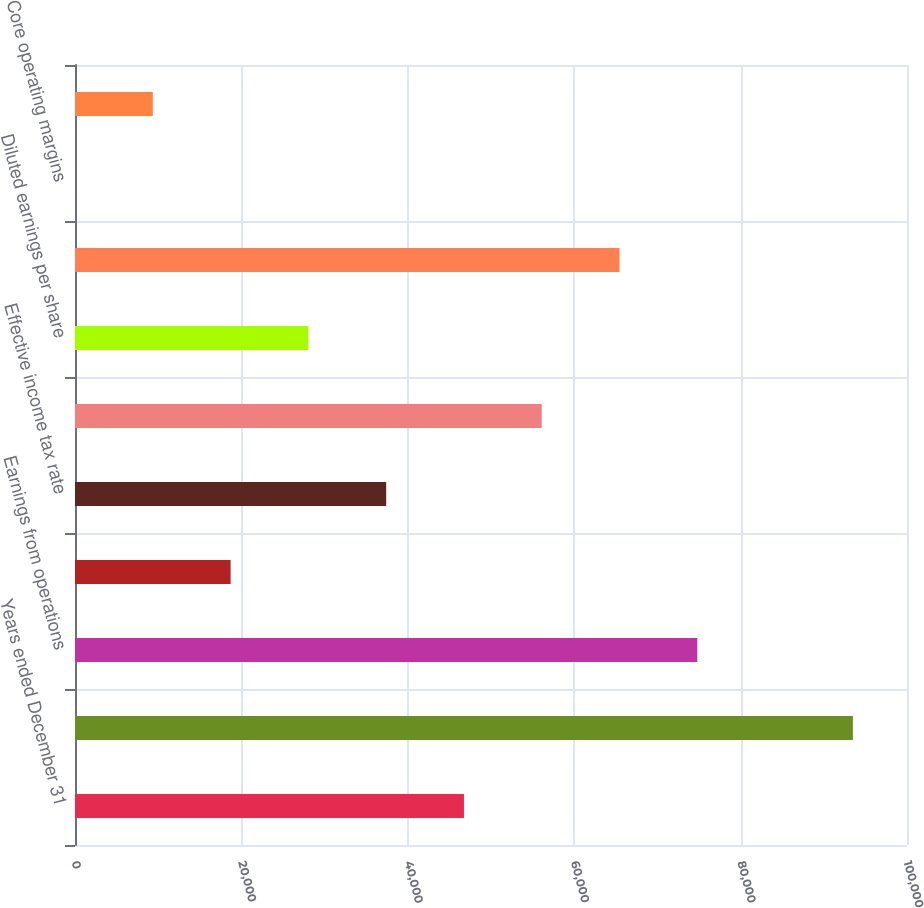Convert chart. <chart><loc_0><loc_0><loc_500><loc_500><bar_chart><fcel>Years ended December 31<fcel>Revenues<fcel>Earnings from operations<fcel>Operating margins<fcel>Effective income tax rate<fcel>Net earnings<fcel>Diluted earnings per share<fcel>Core operating earnings<fcel>Core operating margins<fcel>Core earnings per share<nl><fcel>46750.8<fcel>93496<fcel>74797.9<fcel>18703.6<fcel>37401.7<fcel>56099.8<fcel>28052.7<fcel>65448.8<fcel>5.5<fcel>9354.55<nl></chart> 